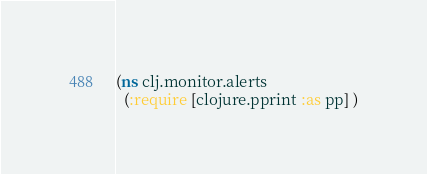<code> <loc_0><loc_0><loc_500><loc_500><_Clojure_>(ns clj.monitor.alerts
  (:require [clojure.pprint :as pp] )</code> 